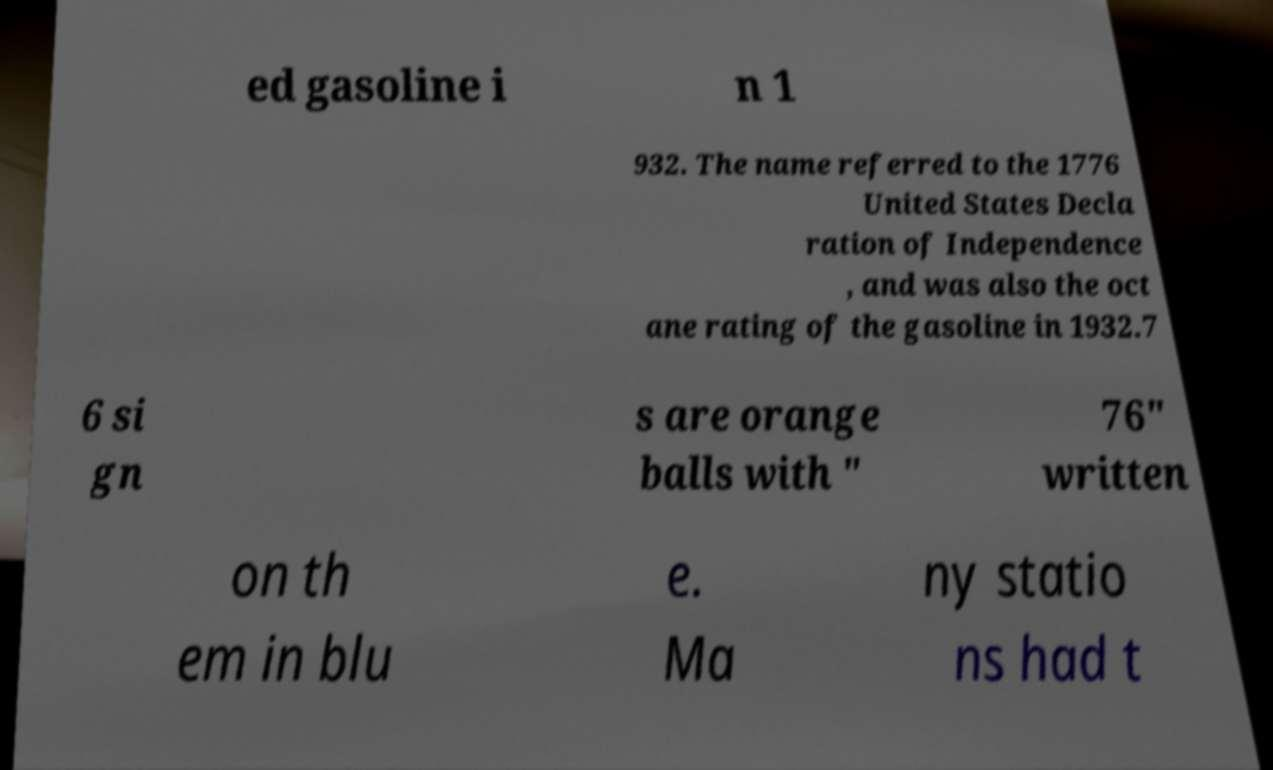I need the written content from this picture converted into text. Can you do that? ed gasoline i n 1 932. The name referred to the 1776 United States Decla ration of Independence , and was also the oct ane rating of the gasoline in 1932.7 6 si gn s are orange balls with " 76" written on th em in blu e. Ma ny statio ns had t 